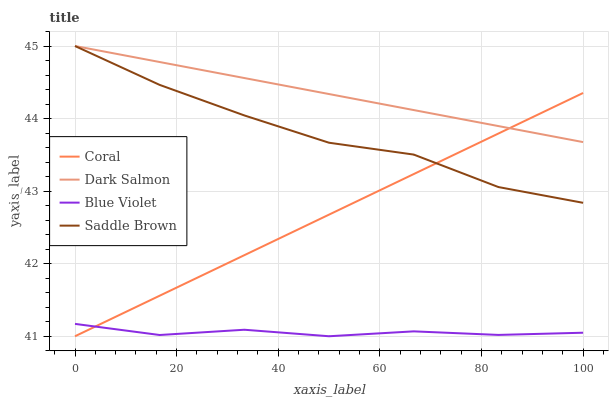Does Blue Violet have the minimum area under the curve?
Answer yes or no. Yes. Does Dark Salmon have the maximum area under the curve?
Answer yes or no. Yes. Does Dark Salmon have the minimum area under the curve?
Answer yes or no. No. Does Blue Violet have the maximum area under the curve?
Answer yes or no. No. Is Dark Salmon the smoothest?
Answer yes or no. Yes. Is Saddle Brown the roughest?
Answer yes or no. Yes. Is Blue Violet the smoothest?
Answer yes or no. No. Is Blue Violet the roughest?
Answer yes or no. No. Does Coral have the lowest value?
Answer yes or no. Yes. Does Dark Salmon have the lowest value?
Answer yes or no. No. Does Saddle Brown have the highest value?
Answer yes or no. Yes. Does Blue Violet have the highest value?
Answer yes or no. No. Is Blue Violet less than Dark Salmon?
Answer yes or no. Yes. Is Dark Salmon greater than Blue Violet?
Answer yes or no. Yes. Does Coral intersect Dark Salmon?
Answer yes or no. Yes. Is Coral less than Dark Salmon?
Answer yes or no. No. Is Coral greater than Dark Salmon?
Answer yes or no. No. Does Blue Violet intersect Dark Salmon?
Answer yes or no. No. 